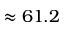<formula> <loc_0><loc_0><loc_500><loc_500>\approx 6 1 . 2</formula> 